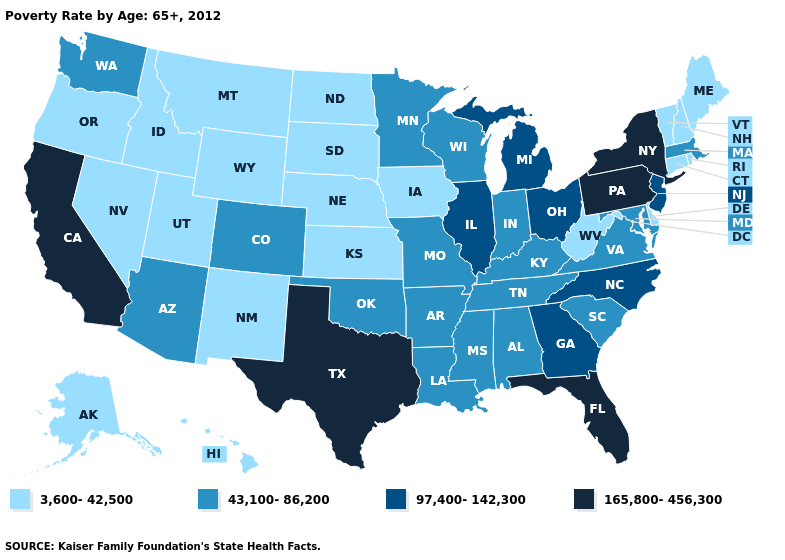What is the value of Mississippi?
Quick response, please. 43,100-86,200. Does Indiana have the lowest value in the USA?
Give a very brief answer. No. Does Minnesota have a higher value than Hawaii?
Concise answer only. Yes. What is the value of Oklahoma?
Concise answer only. 43,100-86,200. Does Minnesota have the lowest value in the USA?
Keep it brief. No. Does Idaho have the lowest value in the USA?
Concise answer only. Yes. Does South Carolina have a lower value than New York?
Quick response, please. Yes. What is the value of Colorado?
Quick response, please. 43,100-86,200. What is the highest value in the Northeast ?
Be succinct. 165,800-456,300. What is the value of Kentucky?
Quick response, please. 43,100-86,200. Name the states that have a value in the range 165,800-456,300?
Be succinct. California, Florida, New York, Pennsylvania, Texas. What is the value of Missouri?
Short answer required. 43,100-86,200. Does Louisiana have the lowest value in the South?
Short answer required. No. What is the highest value in the USA?
Short answer required. 165,800-456,300. Does Maryland have the same value as Arkansas?
Keep it brief. Yes. 